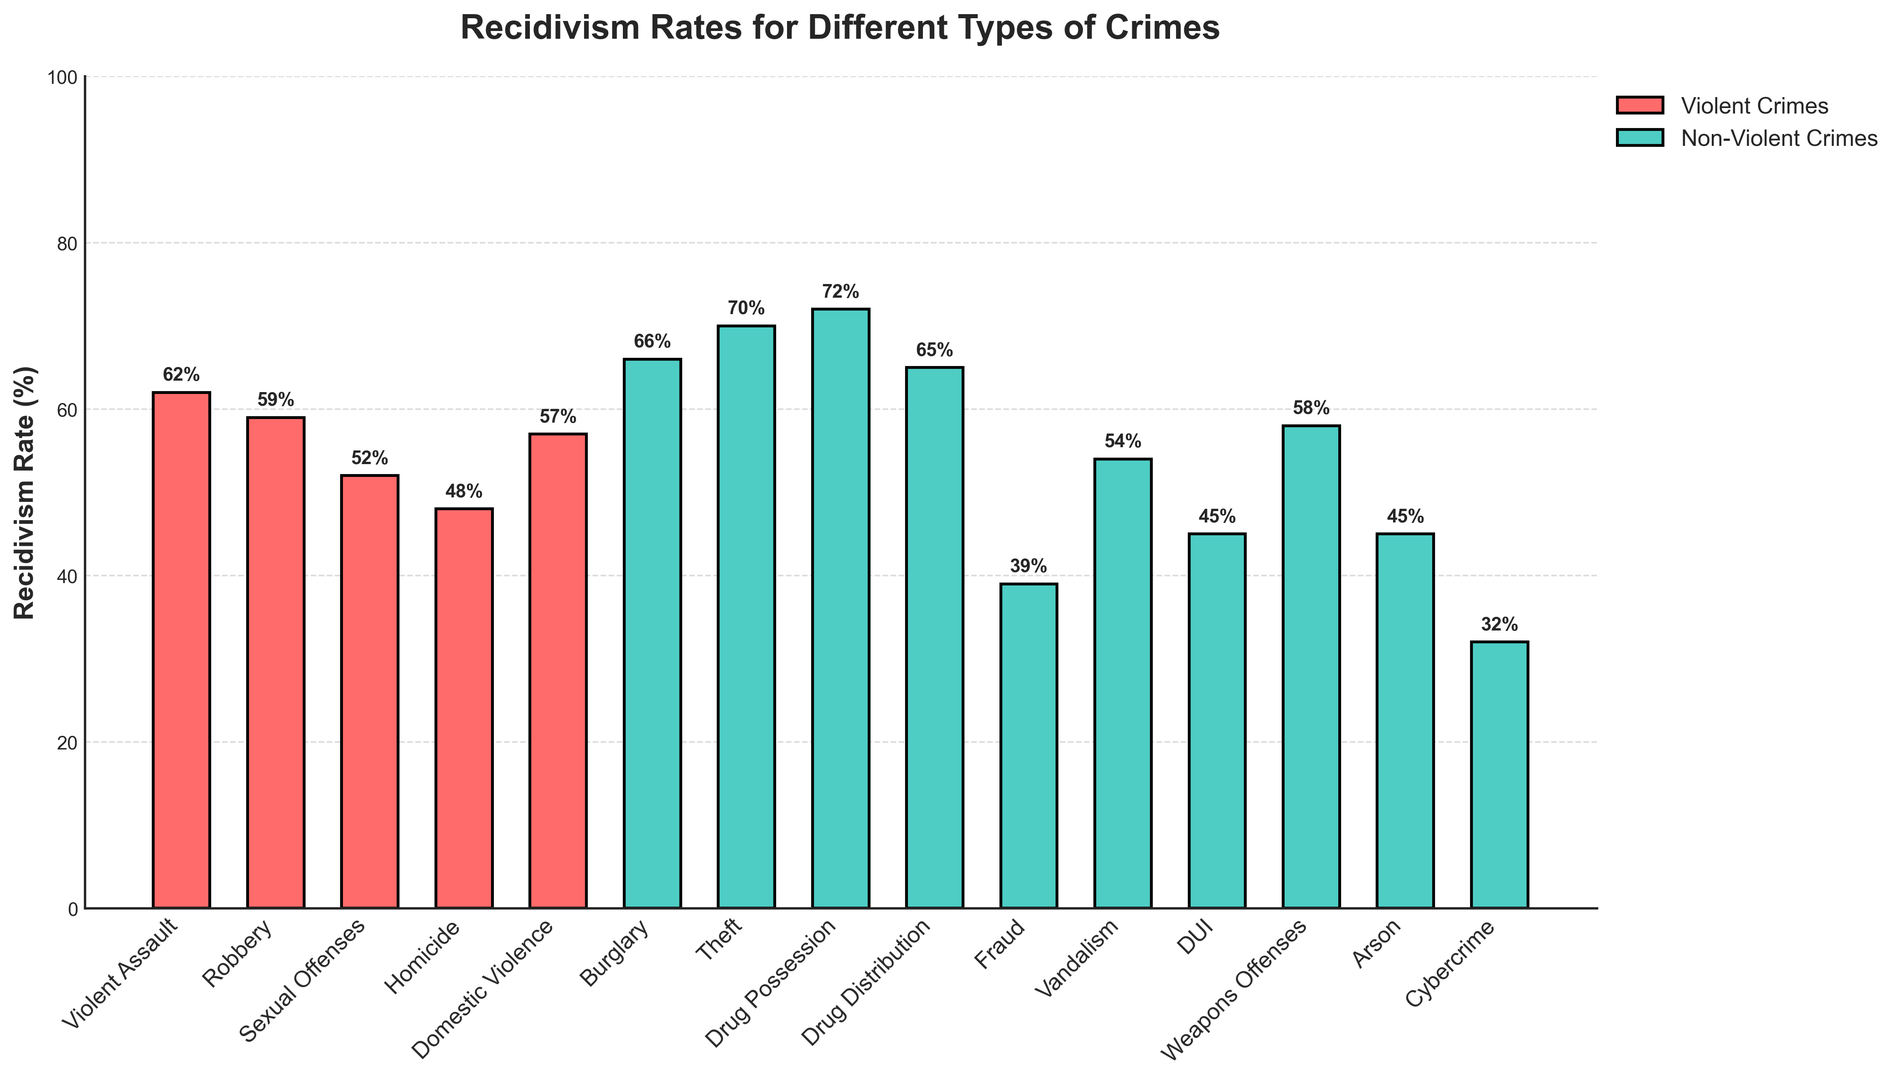Which crime has the highest recidivism rate? Scan through the bar heights or values and identify the crime with the highest percentage value. Drug Possession has the highest rate at 72%.
Answer: Drug Possession Which crime has the lowest recidivism rate? Look for the bar with the smallest height or value. Cybercrime has the lowest rate at 32%.
Answer: Cybercrime How does the recidivism rate for Violent Assault compare to that for Theft? Compare the bar heights of Violent Assault and Theft. Violent Assault is at 62% and Theft is at 70%. Therefore, Theft is higher by 8%.
Answer: Theft is higher by 8% What is the average recidivism rate for violent crimes? Sum the rates for Violent Assault (62%), Robbery (59%), Sexual Offenses (52%), Homicide (48%), and Domestic Violence (57%), then divide by 5. Average = (62 + 59 + 52 + 48 + 57) / 5 = 55.6%
Answer: 55.6% Which has a higher recidivism rate: Drug Distribution or Arson? Compare the bar heights for Drug Distribution (65%) and Arson (45%). Drug Distribution is higher.
Answer: Drug Distribution What is the difference in recidivism rates between Fraud and Vandalism? Subtract the recidivism rate of Fraud (39%) from that of Vandalism (54%). Difference = 54 - 39 = 15%.
Answer: 15% How many non-violent crimes have a recidivism rate above 60%? Identify and count the non-violent crimes with recidivism rates over 60%. These are Burglary (66%), Theft (70%), Drug Possession (72%), and Drug Distribution (65%). Thus, there are 4 non-violent crimes.
Answer: 4 Is the recidivism rate for Weapons Offenses higher than the average rate for violent crimes? Compare the bar height of Weapons Offenses (58%) to the average violent crimes rate (55.6%). Weapons Offenses is higher by 2.4%.
Answer: Yes 